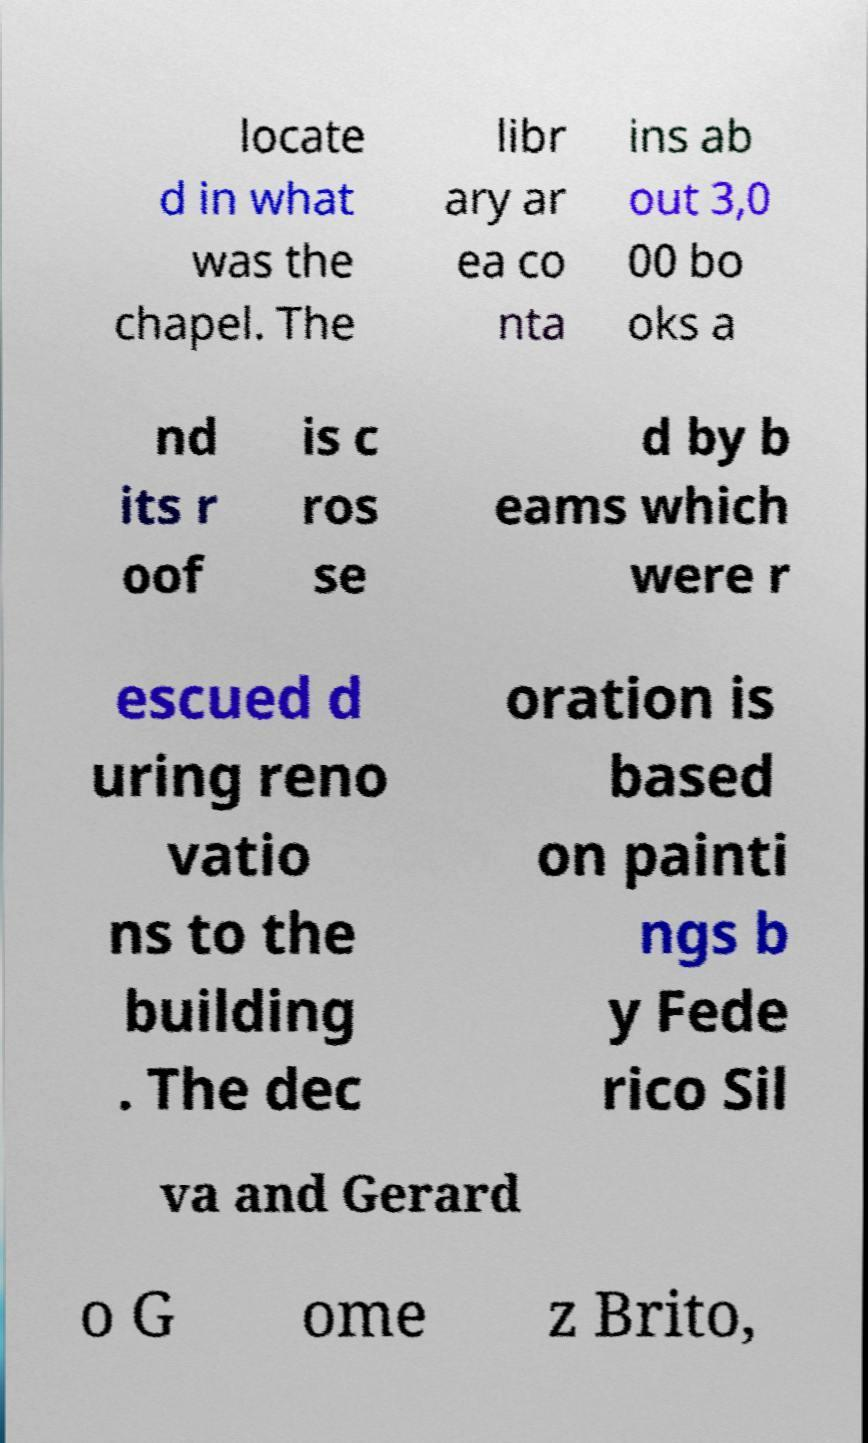Please read and relay the text visible in this image. What does it say? locate d in what was the chapel. The libr ary ar ea co nta ins ab out 3,0 00 bo oks a nd its r oof is c ros se d by b eams which were r escued d uring reno vatio ns to the building . The dec oration is based on painti ngs b y Fede rico Sil va and Gerard o G ome z Brito, 